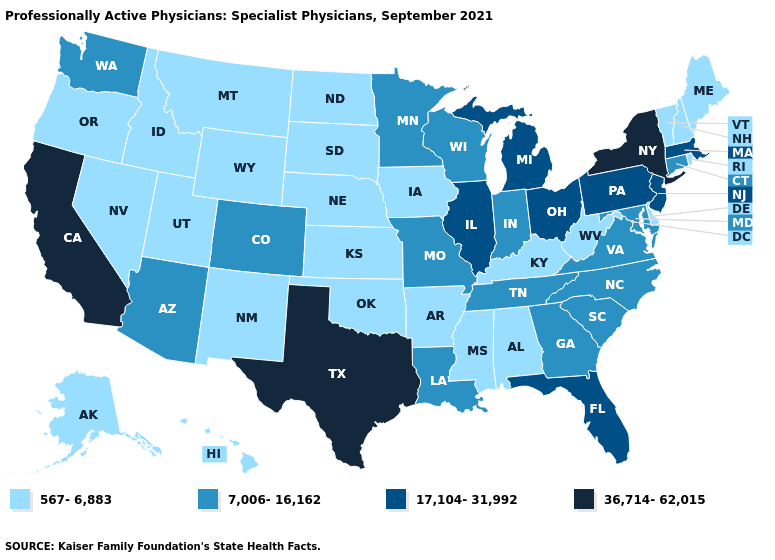What is the lowest value in the USA?
Keep it brief. 567-6,883. Among the states that border Florida , which have the lowest value?
Give a very brief answer. Alabama. Which states have the lowest value in the USA?
Short answer required. Alabama, Alaska, Arkansas, Delaware, Hawaii, Idaho, Iowa, Kansas, Kentucky, Maine, Mississippi, Montana, Nebraska, Nevada, New Hampshire, New Mexico, North Dakota, Oklahoma, Oregon, Rhode Island, South Dakota, Utah, Vermont, West Virginia, Wyoming. What is the highest value in the South ?
Concise answer only. 36,714-62,015. What is the value of Wyoming?
Write a very short answer. 567-6,883. How many symbols are there in the legend?
Give a very brief answer. 4. What is the value of Vermont?
Short answer required. 567-6,883. Among the states that border Oklahoma , which have the highest value?
Short answer required. Texas. Does Texas have the highest value in the USA?
Answer briefly. Yes. Does Iowa have the same value as Michigan?
Write a very short answer. No. What is the value of Kentucky?
Concise answer only. 567-6,883. Name the states that have a value in the range 36,714-62,015?
Concise answer only. California, New York, Texas. Does the map have missing data?
Be succinct. No. Name the states that have a value in the range 36,714-62,015?
Short answer required. California, New York, Texas. 